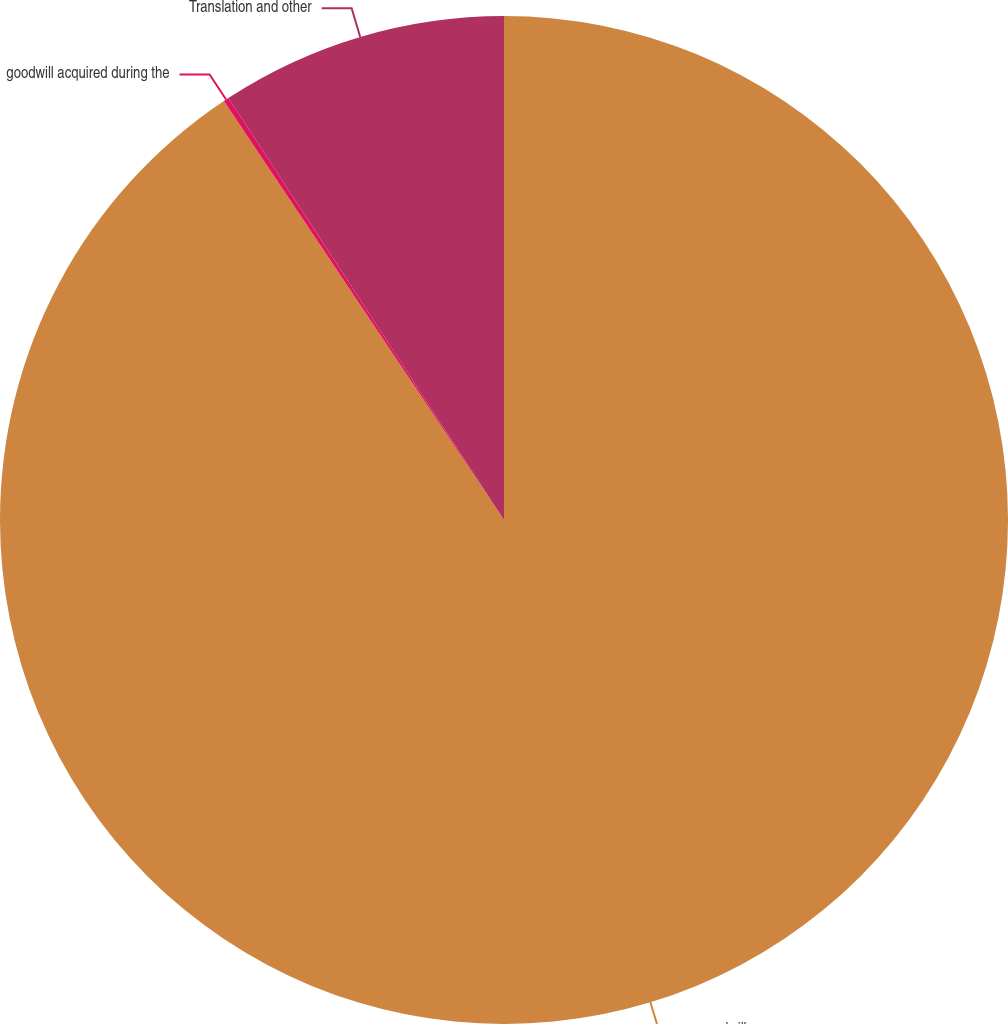Convert chart. <chart><loc_0><loc_0><loc_500><loc_500><pie_chart><fcel>goodwill<fcel>goodwill acquired during the<fcel>Translation and other<nl><fcel>90.62%<fcel>0.17%<fcel>9.21%<nl></chart> 